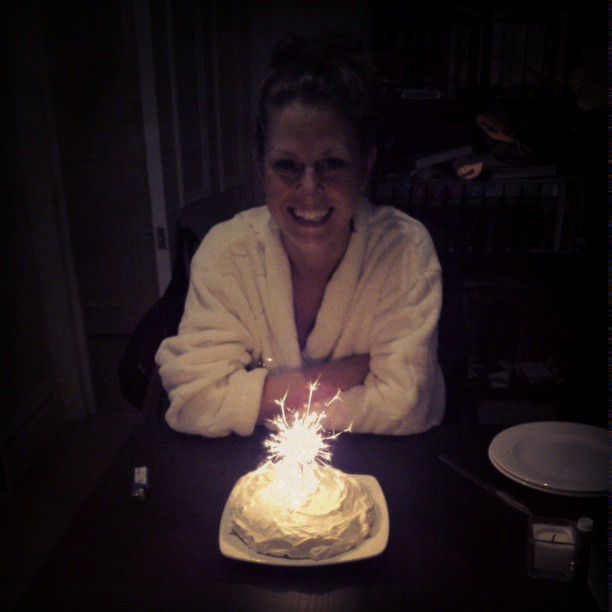What number of sparklers are in this cake? The cake features exactly one sparkler, which beautifully lights up the scene, making the occasion more special. 